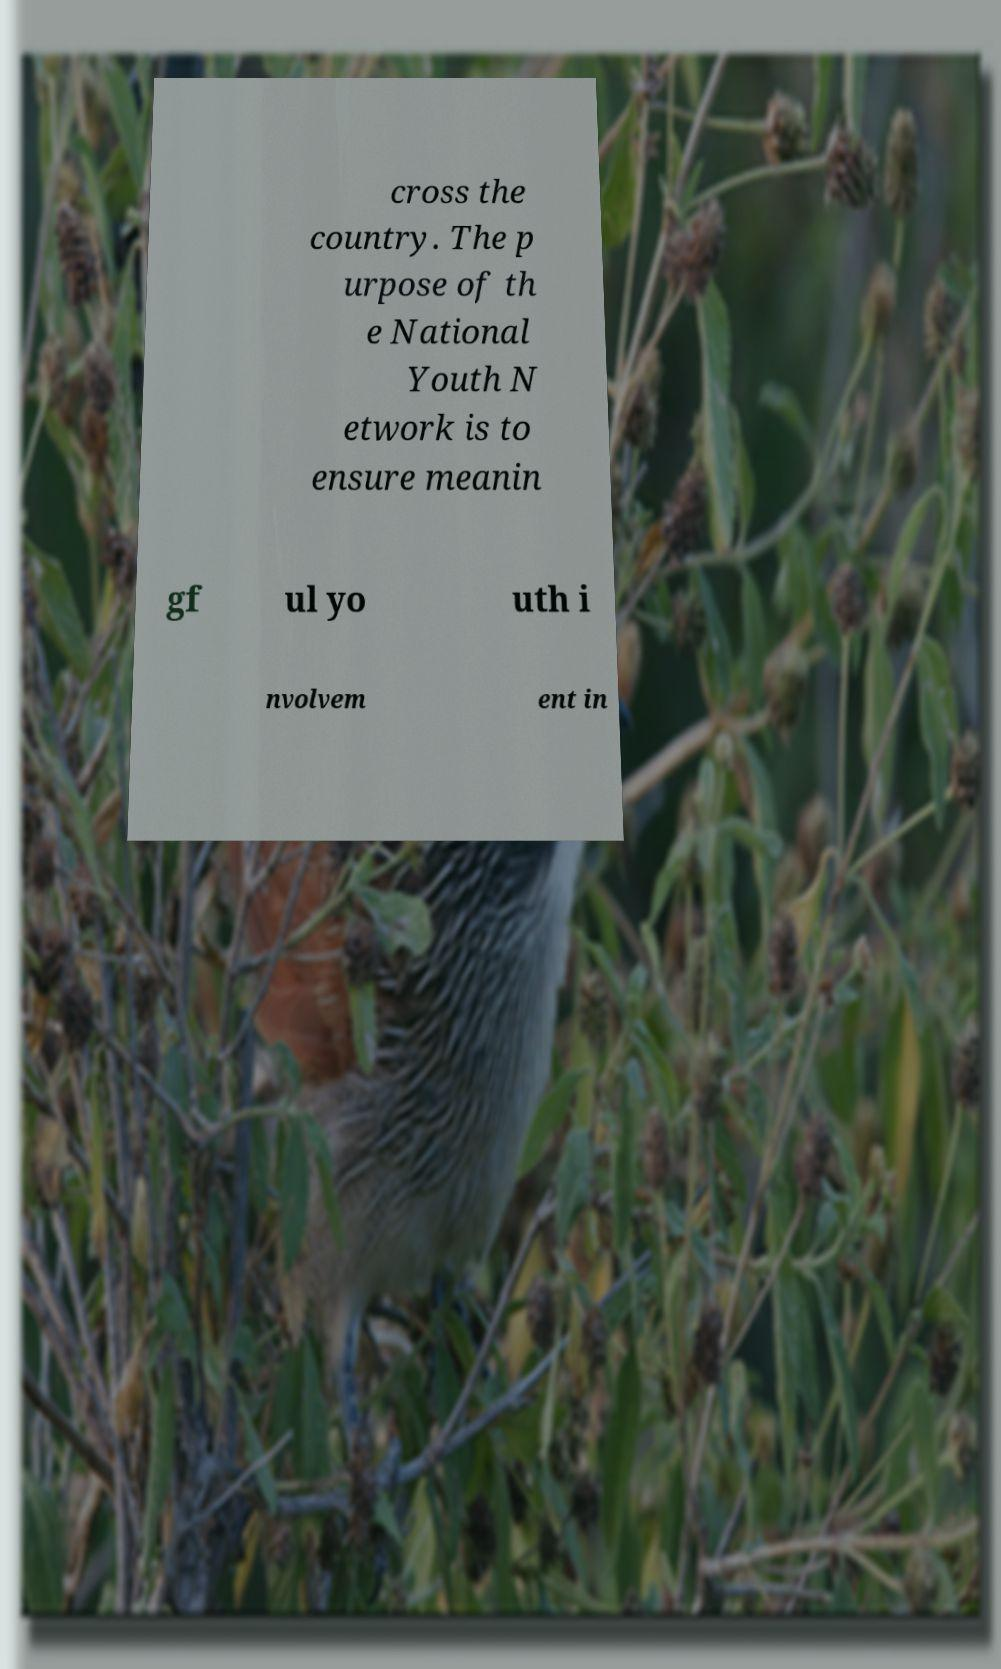Could you assist in decoding the text presented in this image and type it out clearly? cross the country. The p urpose of th e National Youth N etwork is to ensure meanin gf ul yo uth i nvolvem ent in 